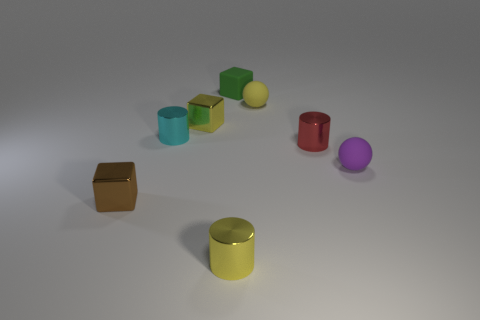How many yellow cubes are the same size as the yellow cylinder?
Offer a very short reply. 1. Are the cube in front of the small red metallic cylinder and the tiny yellow object that is in front of the small brown object made of the same material?
Your answer should be very brief. Yes. Is the number of tiny green matte blocks greater than the number of small gray rubber spheres?
Your answer should be compact. Yes. Is there anything else of the same color as the small matte block?
Your response must be concise. No. Do the tiny purple object and the tiny yellow ball have the same material?
Offer a terse response. Yes. Are there fewer small metallic objects than objects?
Offer a very short reply. Yes. Do the tiny purple matte thing and the yellow matte object have the same shape?
Give a very brief answer. Yes. The tiny rubber cube has what color?
Offer a very short reply. Green. How many other things are made of the same material as the brown cube?
Provide a short and direct response. 4. How many cyan things are big metallic objects or blocks?
Your answer should be very brief. 0. 